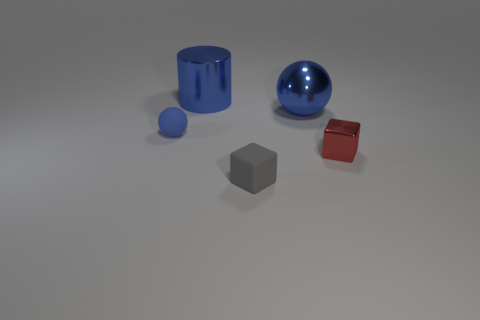Add 3 rubber objects. How many objects exist? 8 Subtract all spheres. How many objects are left? 3 Add 4 blue metallic cylinders. How many blue metallic cylinders exist? 5 Subtract 0 red spheres. How many objects are left? 5 Subtract all blue spheres. Subtract all big green things. How many objects are left? 3 Add 4 blue balls. How many blue balls are left? 6 